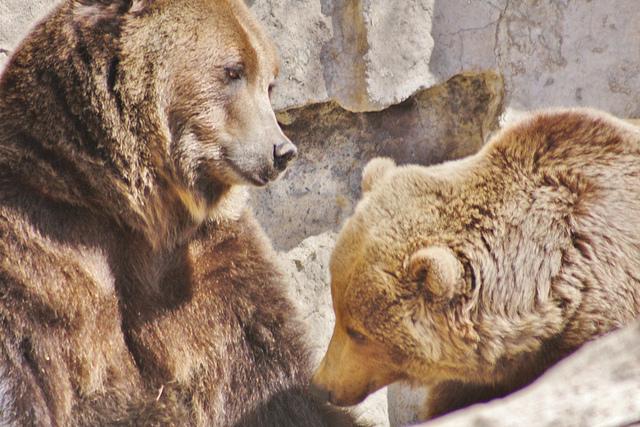Is the animal in the photo standing or sitting?
Answer briefly. Sitting. Are they bears eating?
Answer briefly. No. Do these animals have brown fur?
Answer briefly. Yes. How many bears are here?
Give a very brief answer. 2. 